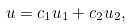<formula> <loc_0><loc_0><loc_500><loc_500>u = c _ { 1 } u _ { 1 } + c _ { 2 } u _ { 2 } ,</formula> 